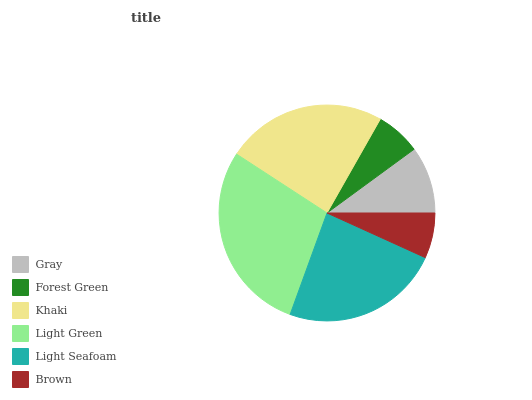Is Forest Green the minimum?
Answer yes or no. Yes. Is Light Green the maximum?
Answer yes or no. Yes. Is Khaki the minimum?
Answer yes or no. No. Is Khaki the maximum?
Answer yes or no. No. Is Khaki greater than Forest Green?
Answer yes or no. Yes. Is Forest Green less than Khaki?
Answer yes or no. Yes. Is Forest Green greater than Khaki?
Answer yes or no. No. Is Khaki less than Forest Green?
Answer yes or no. No. Is Light Seafoam the high median?
Answer yes or no. Yes. Is Gray the low median?
Answer yes or no. Yes. Is Khaki the high median?
Answer yes or no. No. Is Brown the low median?
Answer yes or no. No. 